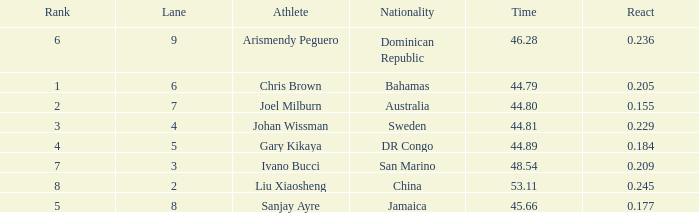How many total Rank listings have Liu Xiaosheng listed as the athlete with a react entry that is smaller than 0.245? 0.0. 